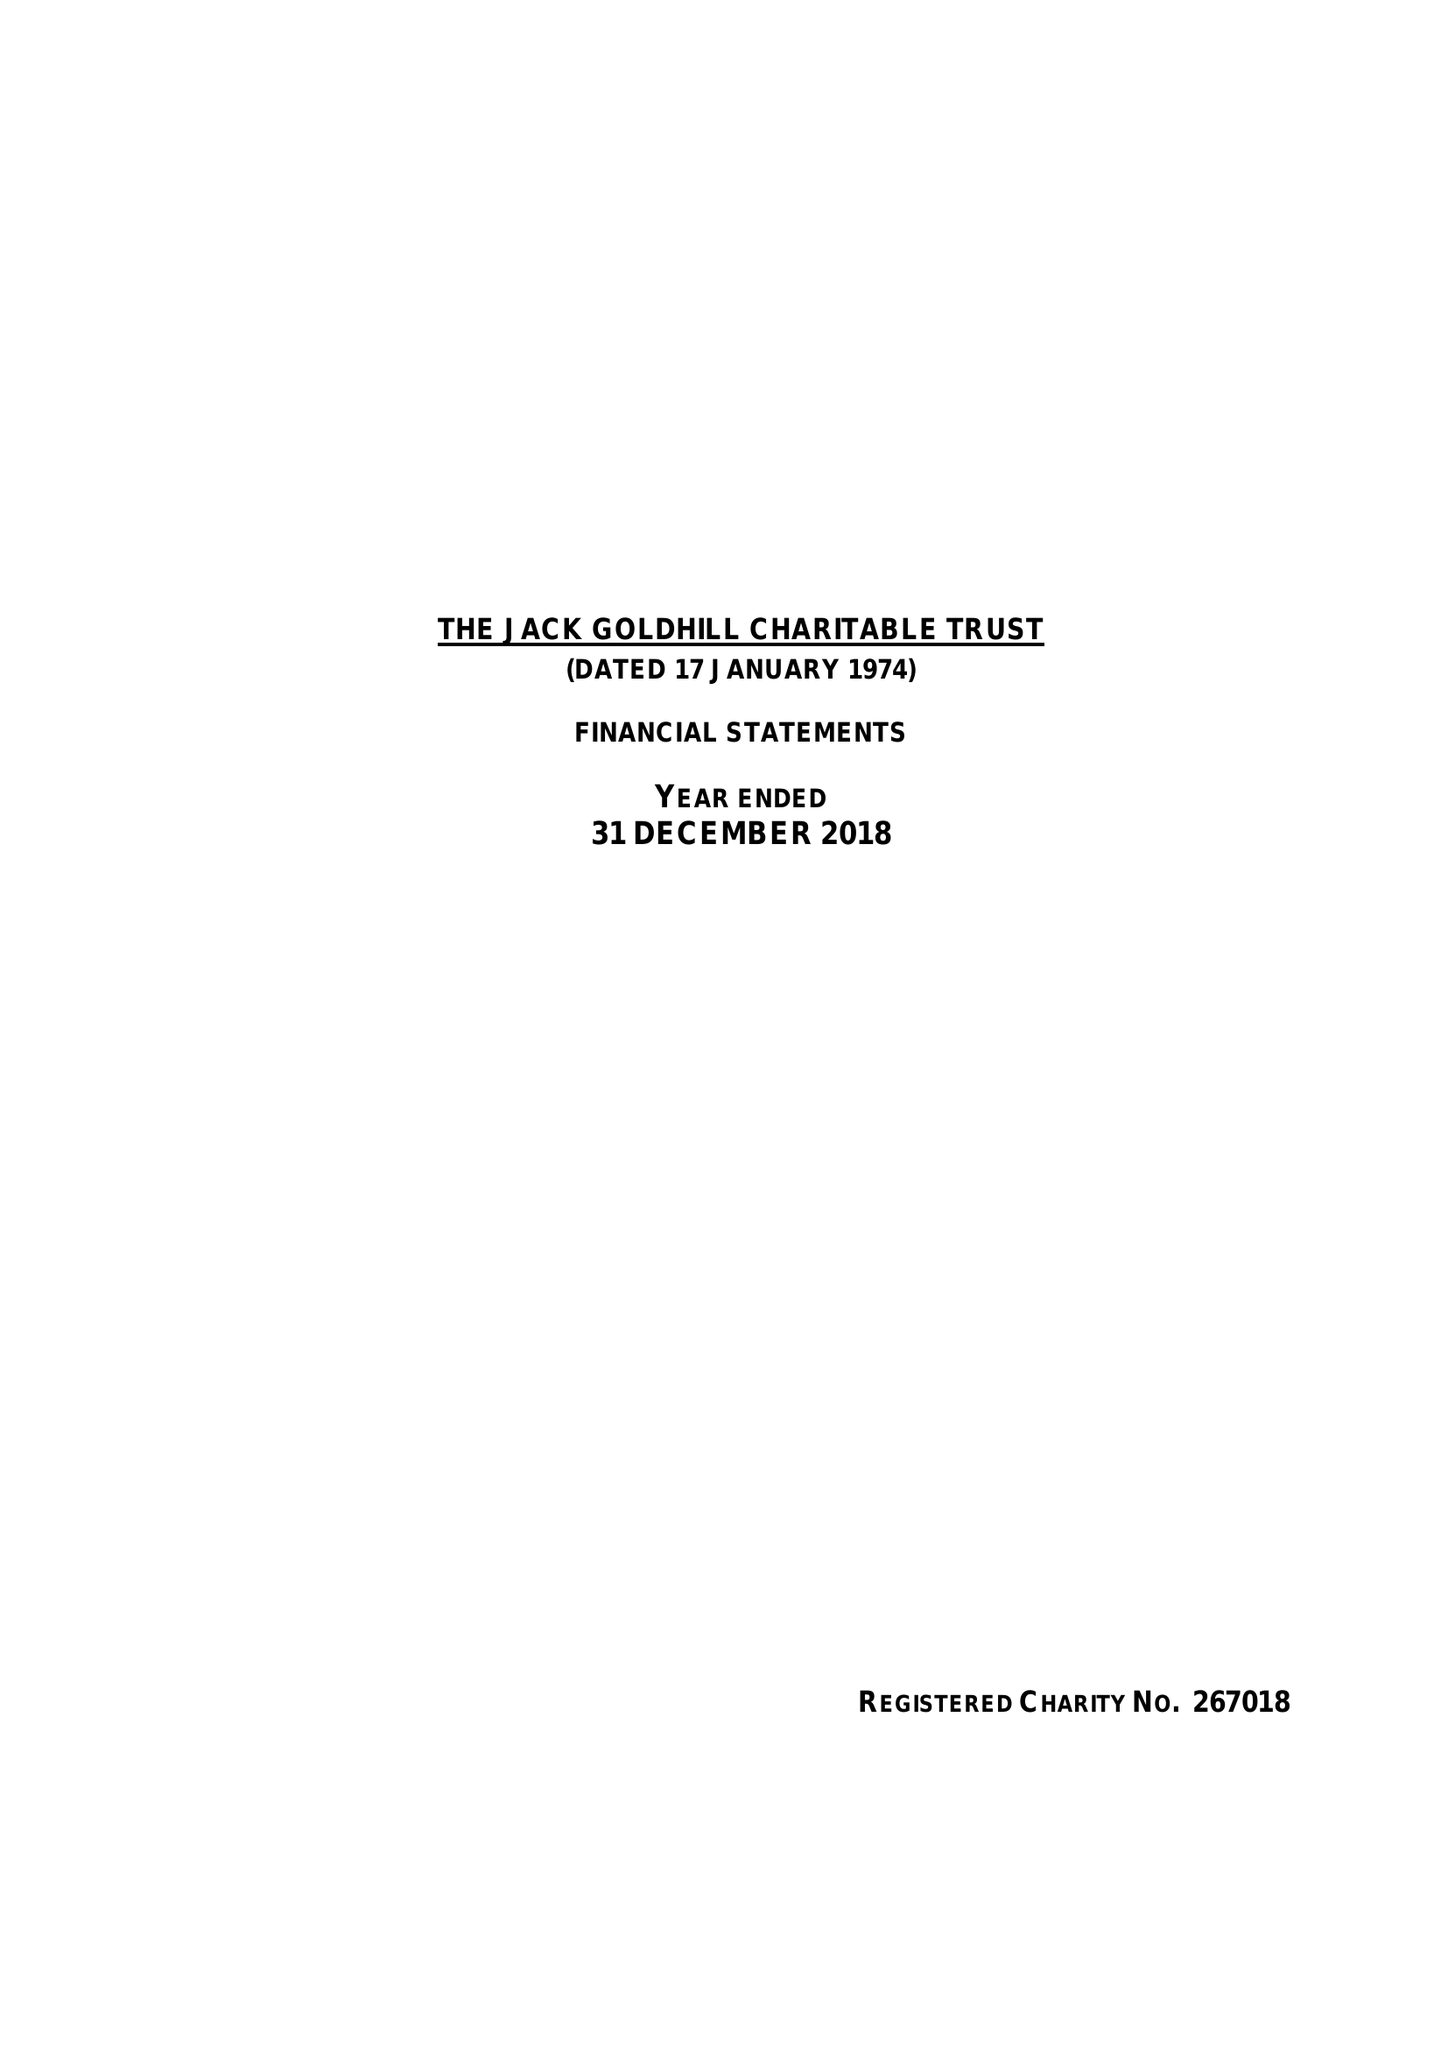What is the value for the report_date?
Answer the question using a single word or phrase. 2018-12-31 